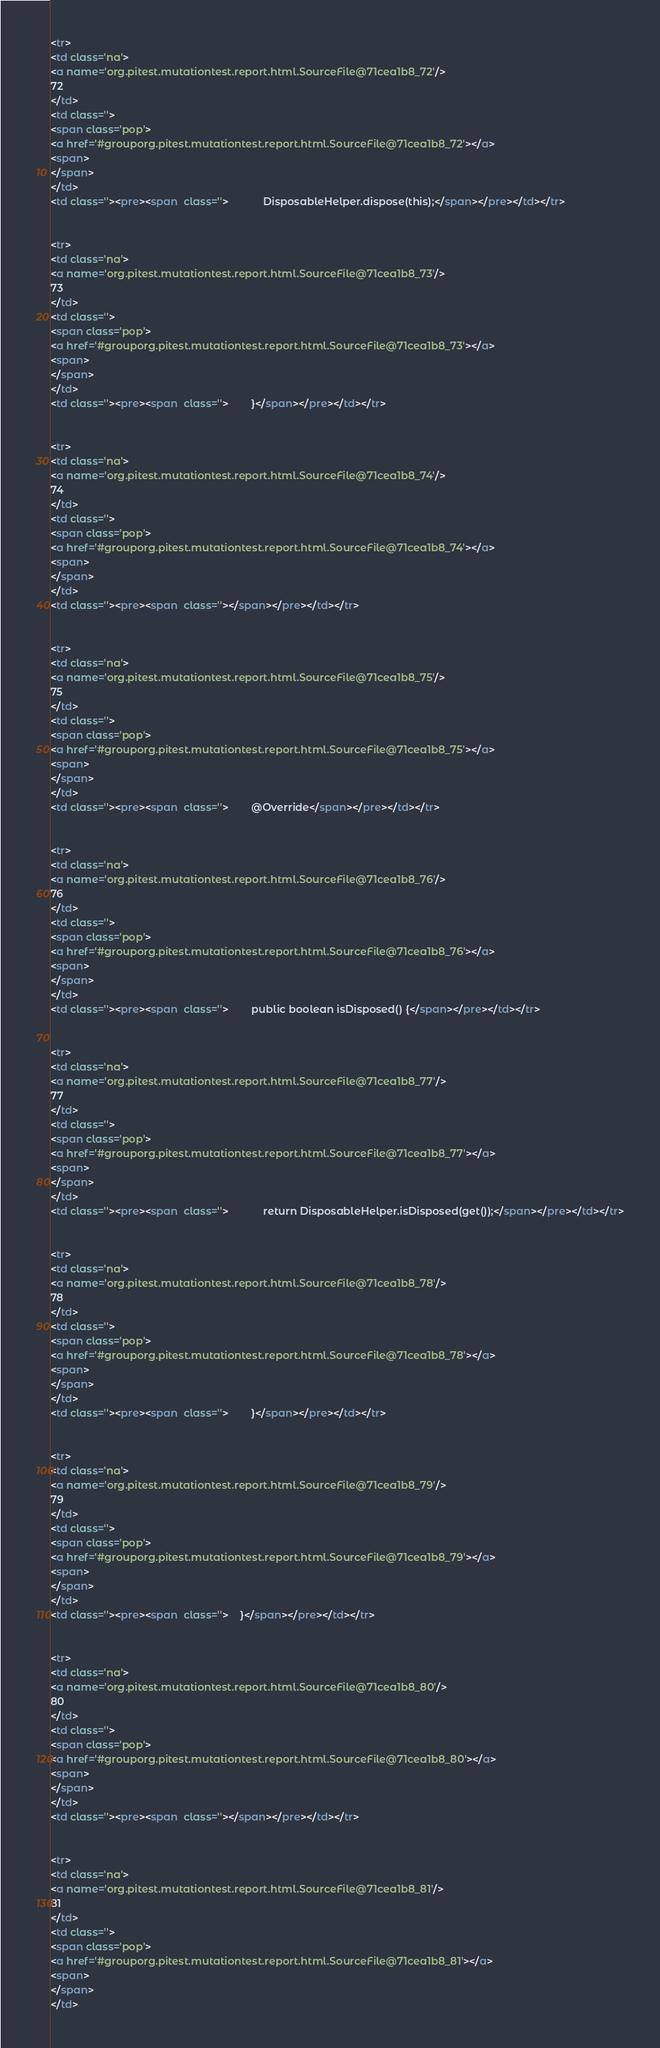<code> <loc_0><loc_0><loc_500><loc_500><_HTML_><tr>
<td class='na'>
<a name='org.pitest.mutationtest.report.html.SourceFile@71cea1b8_72'/>
72
</td>
<td class=''>
<span class='pop'>
<a href='#grouporg.pitest.mutationtest.report.html.SourceFile@71cea1b8_72'></a>
<span>
</span>
</td>
<td class=''><pre><span  class=''>            DisposableHelper.dispose(this);</span></pre></td></tr>


<tr>
<td class='na'>
<a name='org.pitest.mutationtest.report.html.SourceFile@71cea1b8_73'/>
73
</td>
<td class=''>
<span class='pop'>
<a href='#grouporg.pitest.mutationtest.report.html.SourceFile@71cea1b8_73'></a>
<span>
</span>
</td>
<td class=''><pre><span  class=''>        }</span></pre></td></tr>


<tr>
<td class='na'>
<a name='org.pitest.mutationtest.report.html.SourceFile@71cea1b8_74'/>
74
</td>
<td class=''>
<span class='pop'>
<a href='#grouporg.pitest.mutationtest.report.html.SourceFile@71cea1b8_74'></a>
<span>
</span>
</td>
<td class=''><pre><span  class=''></span></pre></td></tr>


<tr>
<td class='na'>
<a name='org.pitest.mutationtest.report.html.SourceFile@71cea1b8_75'/>
75
</td>
<td class=''>
<span class='pop'>
<a href='#grouporg.pitest.mutationtest.report.html.SourceFile@71cea1b8_75'></a>
<span>
</span>
</td>
<td class=''><pre><span  class=''>        @Override</span></pre></td></tr>


<tr>
<td class='na'>
<a name='org.pitest.mutationtest.report.html.SourceFile@71cea1b8_76'/>
76
</td>
<td class=''>
<span class='pop'>
<a href='#grouporg.pitest.mutationtest.report.html.SourceFile@71cea1b8_76'></a>
<span>
</span>
</td>
<td class=''><pre><span  class=''>        public boolean isDisposed() {</span></pre></td></tr>


<tr>
<td class='na'>
<a name='org.pitest.mutationtest.report.html.SourceFile@71cea1b8_77'/>
77
</td>
<td class=''>
<span class='pop'>
<a href='#grouporg.pitest.mutationtest.report.html.SourceFile@71cea1b8_77'></a>
<span>
</span>
</td>
<td class=''><pre><span  class=''>            return DisposableHelper.isDisposed(get());</span></pre></td></tr>


<tr>
<td class='na'>
<a name='org.pitest.mutationtest.report.html.SourceFile@71cea1b8_78'/>
78
</td>
<td class=''>
<span class='pop'>
<a href='#grouporg.pitest.mutationtest.report.html.SourceFile@71cea1b8_78'></a>
<span>
</span>
</td>
<td class=''><pre><span  class=''>        }</span></pre></td></tr>


<tr>
<td class='na'>
<a name='org.pitest.mutationtest.report.html.SourceFile@71cea1b8_79'/>
79
</td>
<td class=''>
<span class='pop'>
<a href='#grouporg.pitest.mutationtest.report.html.SourceFile@71cea1b8_79'></a>
<span>
</span>
</td>
<td class=''><pre><span  class=''>    }</span></pre></td></tr>


<tr>
<td class='na'>
<a name='org.pitest.mutationtest.report.html.SourceFile@71cea1b8_80'/>
80
</td>
<td class=''>
<span class='pop'>
<a href='#grouporg.pitest.mutationtest.report.html.SourceFile@71cea1b8_80'></a>
<span>
</span>
</td>
<td class=''><pre><span  class=''></span></pre></td></tr>


<tr>
<td class='na'>
<a name='org.pitest.mutationtest.report.html.SourceFile@71cea1b8_81'/>
81
</td>
<td class=''>
<span class='pop'>
<a href='#grouporg.pitest.mutationtest.report.html.SourceFile@71cea1b8_81'></a>
<span>
</span>
</td></code> 